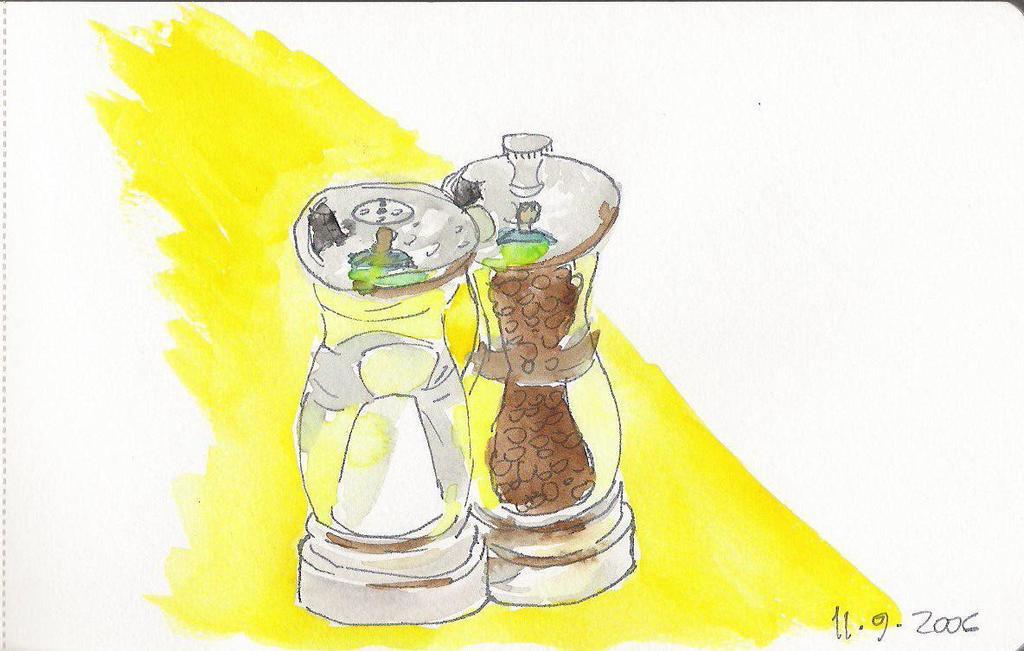What year was this painting produced?
Ensure brevity in your answer.  2006. What month was the painting produced in?
Keep it short and to the point. November. 